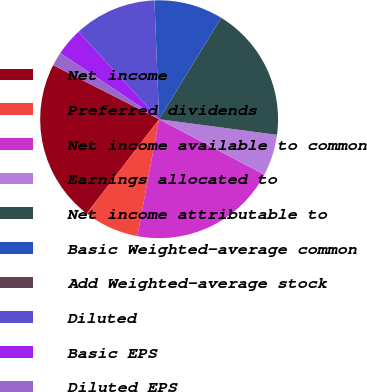Convert chart to OTSL. <chart><loc_0><loc_0><loc_500><loc_500><pie_chart><fcel>Net income<fcel>Preferred dividends<fcel>Net income available to common<fcel>Earnings allocated to<fcel>Net income attributable to<fcel>Basic Weighted-average common<fcel>Add Weighted-average stock<fcel>Diluted<fcel>Basic EPS<fcel>Diluted EPS<nl><fcel>22.08%<fcel>7.49%<fcel>20.21%<fcel>5.62%<fcel>18.35%<fcel>9.36%<fcel>0.01%<fcel>11.23%<fcel>3.75%<fcel>1.88%<nl></chart> 